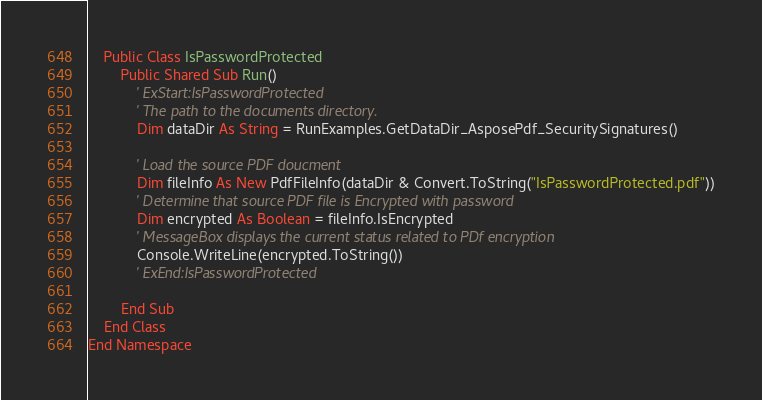<code> <loc_0><loc_0><loc_500><loc_500><_VisualBasic_>    Public Class IsPasswordProtected
        Public Shared Sub Run()
            ' ExStart:IsPasswordProtected
            ' The path to the documents directory.
            Dim dataDir As String = RunExamples.GetDataDir_AsposePdf_SecuritySignatures()

            ' Load the source PDF doucment
            Dim fileInfo As New PdfFileInfo(dataDir & Convert.ToString("IsPasswordProtected.pdf"))
            ' Determine that source PDF file is Encrypted with password
            Dim encrypted As Boolean = fileInfo.IsEncrypted
            ' MessageBox displays the current status related to PDf encryption
            Console.WriteLine(encrypted.ToString())
            ' ExEnd:IsPasswordProtected

        End Sub
    End Class
End Namespace
</code> 